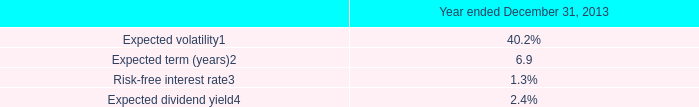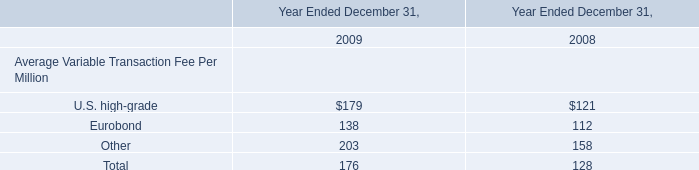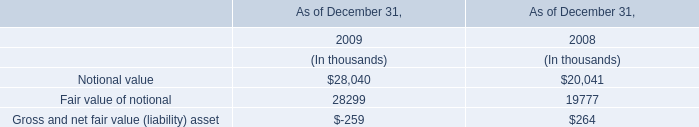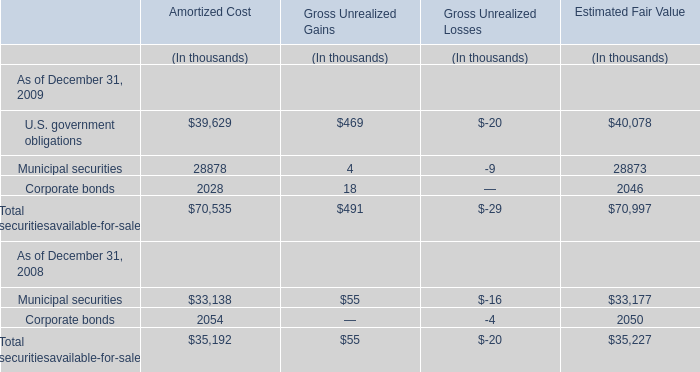In the year with larger Fair value of notional, what's the increasing rate of Notional value? 
Computations: ((28040 - 20041) / 20041)
Answer: 0.39913. 